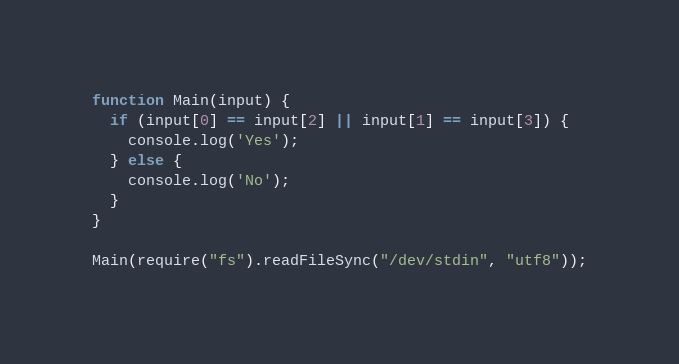<code> <loc_0><loc_0><loc_500><loc_500><_JavaScript_>function Main(input) {
  if (input[0] == input[2] || input[1] == input[3]) {
    console.log('Yes');
  } else {
    console.log('No');
  }
}

Main(require("fs").readFileSync("/dev/stdin", "utf8"));</code> 